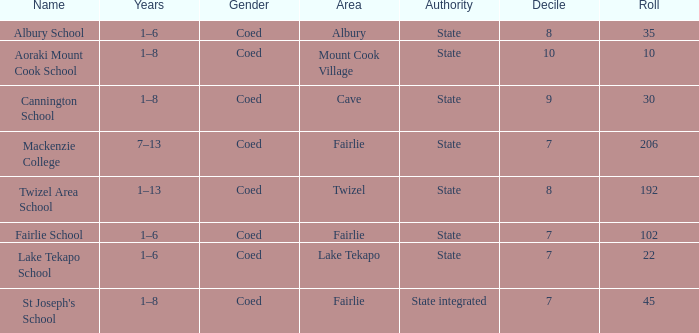Would you be able to parse every entry in this table? {'header': ['Name', 'Years', 'Gender', 'Area', 'Authority', 'Decile', 'Roll'], 'rows': [['Albury School', '1–6', 'Coed', 'Albury', 'State', '8', '35'], ['Aoraki Mount Cook School', '1–8', 'Coed', 'Mount Cook Village', 'State', '10', '10'], ['Cannington School', '1–8', 'Coed', 'Cave', 'State', '9', '30'], ['Mackenzie College', '7–13', 'Coed', 'Fairlie', 'State', '7', '206'], ['Twizel Area School', '1–13', 'Coed', 'Twizel', 'State', '8', '192'], ['Fairlie School', '1–6', 'Coed', 'Fairlie', 'State', '7', '102'], ['Lake Tekapo School', '1–6', 'Coed', 'Lake Tekapo', 'State', '7', '22'], ["St Joseph's School", '1–8', 'Coed', 'Fairlie', 'State integrated', '7', '45']]} What is the total Decile that has a state authority, fairlie area and roll smarter than 206? 1.0. 